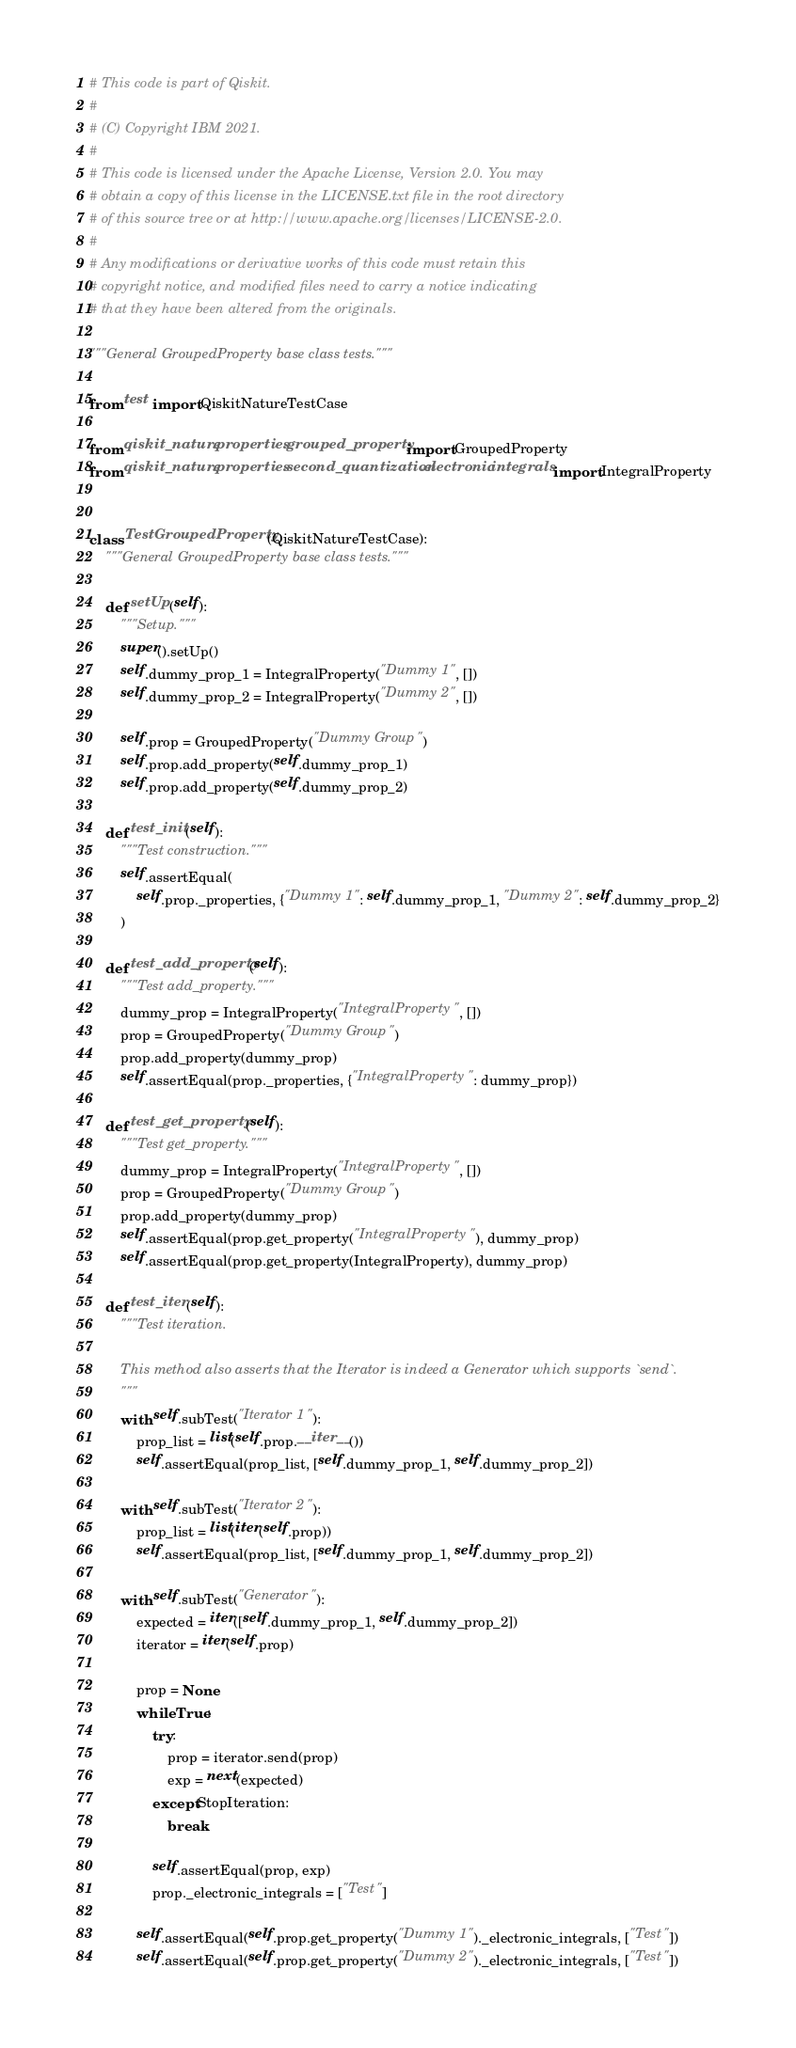Convert code to text. <code><loc_0><loc_0><loc_500><loc_500><_Python_># This code is part of Qiskit.
#
# (C) Copyright IBM 2021.
#
# This code is licensed under the Apache License, Version 2.0. You may
# obtain a copy of this license in the LICENSE.txt file in the root directory
# of this source tree or at http://www.apache.org/licenses/LICENSE-2.0.
#
# Any modifications or derivative works of this code must retain this
# copyright notice, and modified files need to carry a notice indicating
# that they have been altered from the originals.

"""General GroupedProperty base class tests."""

from test import QiskitNatureTestCase

from qiskit_nature.properties.grouped_property import GroupedProperty
from qiskit_nature.properties.second_quantization.electronic.integrals import IntegralProperty


class TestGroupedProperty(QiskitNatureTestCase):
    """General GroupedProperty base class tests."""

    def setUp(self):
        """Setup."""
        super().setUp()
        self.dummy_prop_1 = IntegralProperty("Dummy 1", [])
        self.dummy_prop_2 = IntegralProperty("Dummy 2", [])

        self.prop = GroupedProperty("Dummy Group")
        self.prop.add_property(self.dummy_prop_1)
        self.prop.add_property(self.dummy_prop_2)

    def test_init(self):
        """Test construction."""
        self.assertEqual(
            self.prop._properties, {"Dummy 1": self.dummy_prop_1, "Dummy 2": self.dummy_prop_2}
        )

    def test_add_property(self):
        """Test add_property."""
        dummy_prop = IntegralProperty("IntegralProperty", [])
        prop = GroupedProperty("Dummy Group")
        prop.add_property(dummy_prop)
        self.assertEqual(prop._properties, {"IntegralProperty": dummy_prop})

    def test_get_property(self):
        """Test get_property."""
        dummy_prop = IntegralProperty("IntegralProperty", [])
        prop = GroupedProperty("Dummy Group")
        prop.add_property(dummy_prop)
        self.assertEqual(prop.get_property("IntegralProperty"), dummy_prop)
        self.assertEqual(prop.get_property(IntegralProperty), dummy_prop)

    def test_iter(self):
        """Test iteration.

        This method also asserts that the Iterator is indeed a Generator which supports `send`.
        """
        with self.subTest("Iterator 1"):
            prop_list = list(self.prop.__iter__())
            self.assertEqual(prop_list, [self.dummy_prop_1, self.dummy_prop_2])

        with self.subTest("Iterator 2"):
            prop_list = list(iter(self.prop))
            self.assertEqual(prop_list, [self.dummy_prop_1, self.dummy_prop_2])

        with self.subTest("Generator"):
            expected = iter([self.dummy_prop_1, self.dummy_prop_2])
            iterator = iter(self.prop)

            prop = None
            while True:
                try:
                    prop = iterator.send(prop)
                    exp = next(expected)
                except StopIteration:
                    break

                self.assertEqual(prop, exp)
                prop._electronic_integrals = ["Test"]

            self.assertEqual(self.prop.get_property("Dummy 1")._electronic_integrals, ["Test"])
            self.assertEqual(self.prop.get_property("Dummy 2")._electronic_integrals, ["Test"])
</code> 